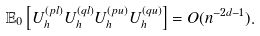Convert formula to latex. <formula><loc_0><loc_0><loc_500><loc_500>\mathbb { E } _ { 0 } \left [ U _ { h } ^ { ( p l ) } U _ { h } ^ { ( q l ) } U _ { h } ^ { ( p u ) } U _ { h } ^ { ( q u ) } \right ] = O ( n ^ { - 2 d - 1 } ) .</formula> 